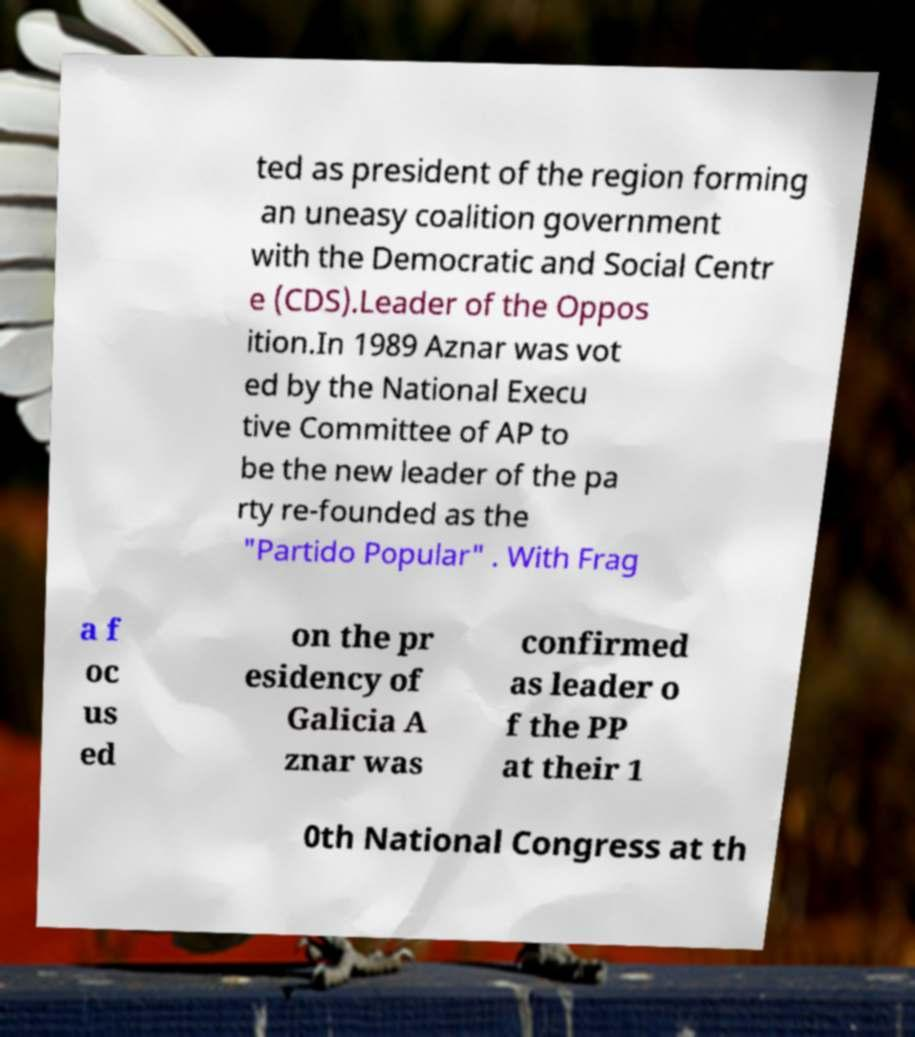Could you assist in decoding the text presented in this image and type it out clearly? ted as president of the region forming an uneasy coalition government with the Democratic and Social Centr e (CDS).Leader of the Oppos ition.In 1989 Aznar was vot ed by the National Execu tive Committee of AP to be the new leader of the pa rty re-founded as the "Partido Popular" . With Frag a f oc us ed on the pr esidency of Galicia A znar was confirmed as leader o f the PP at their 1 0th National Congress at th 